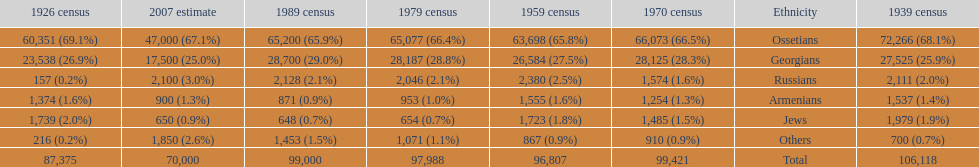How many ethnicity is there? 6. 